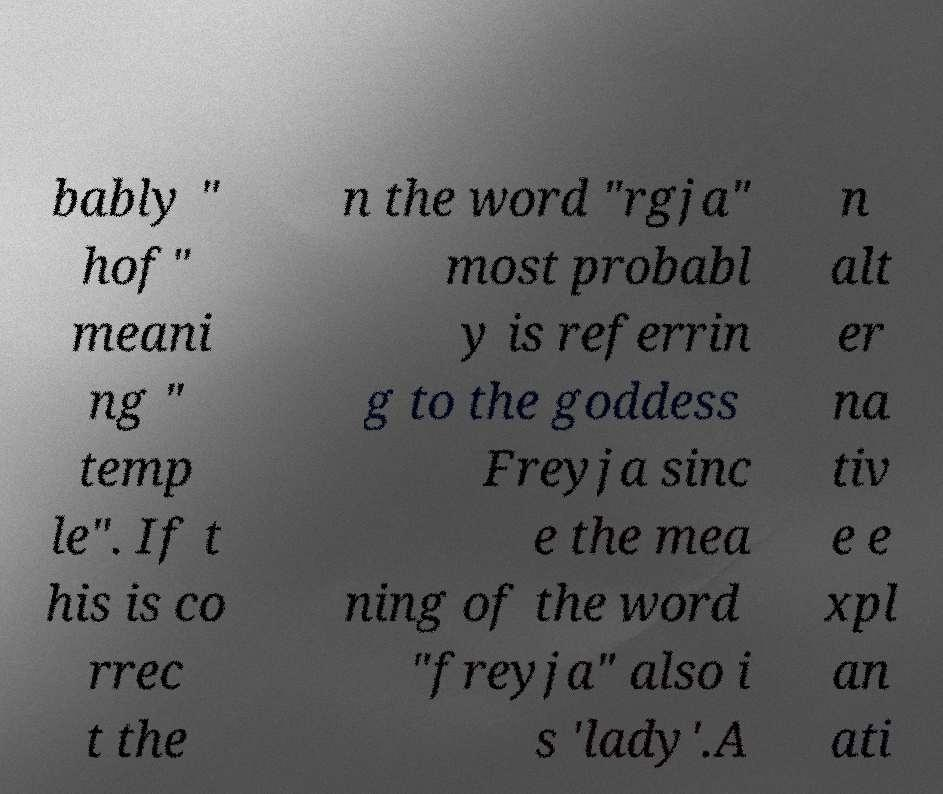There's text embedded in this image that I need extracted. Can you transcribe it verbatim? bably " hof" meani ng " temp le". If t his is co rrec t the n the word "rgja" most probabl y is referrin g to the goddess Freyja sinc e the mea ning of the word "freyja" also i s 'lady'.A n alt er na tiv e e xpl an ati 